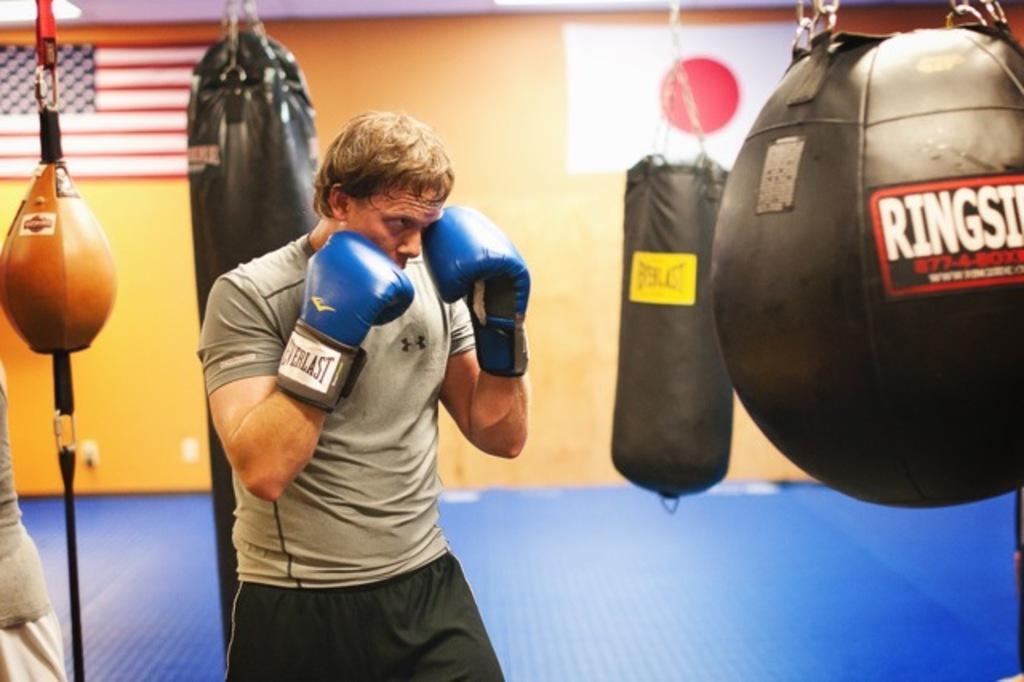In one or two sentences, can you explain what this image depicts? In this picture we can see a man wore gloves and in the background we can see flags on the wall. 